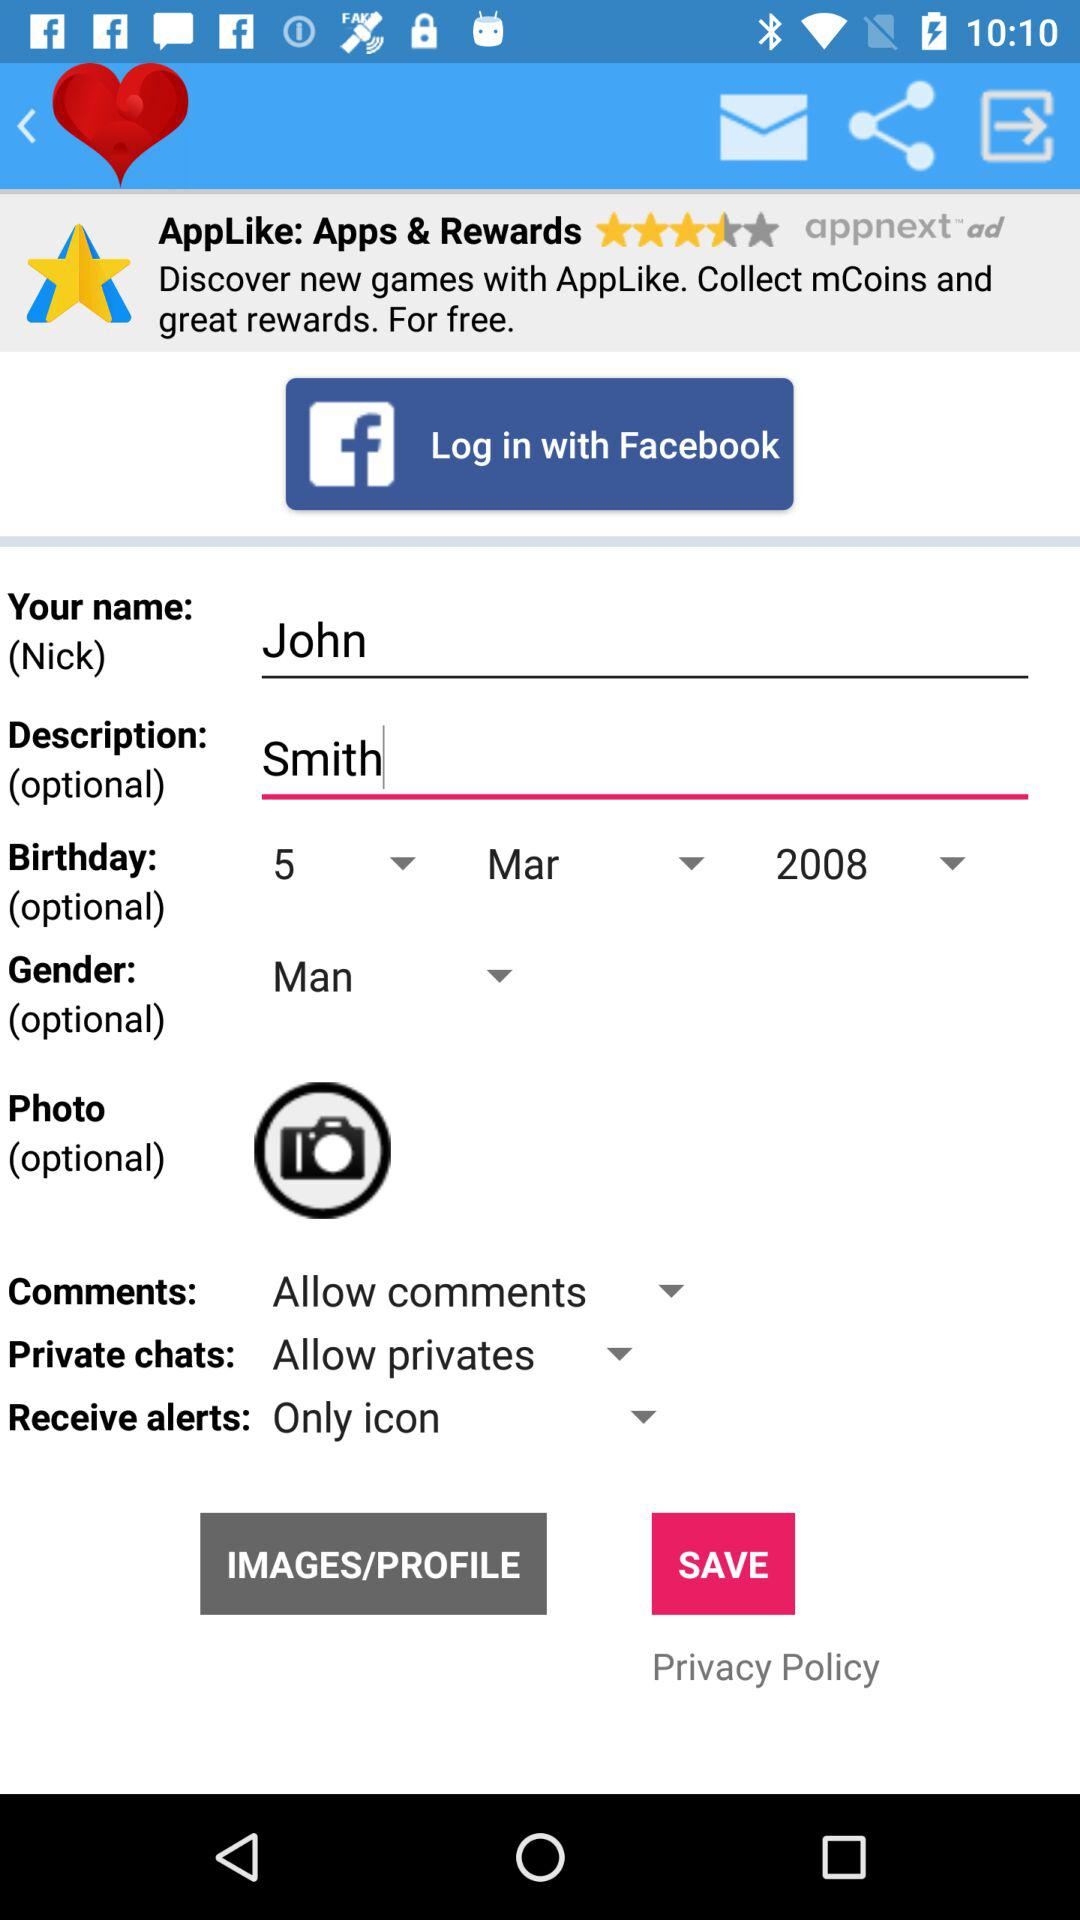How can we log in? You can log in with "Facebook". 